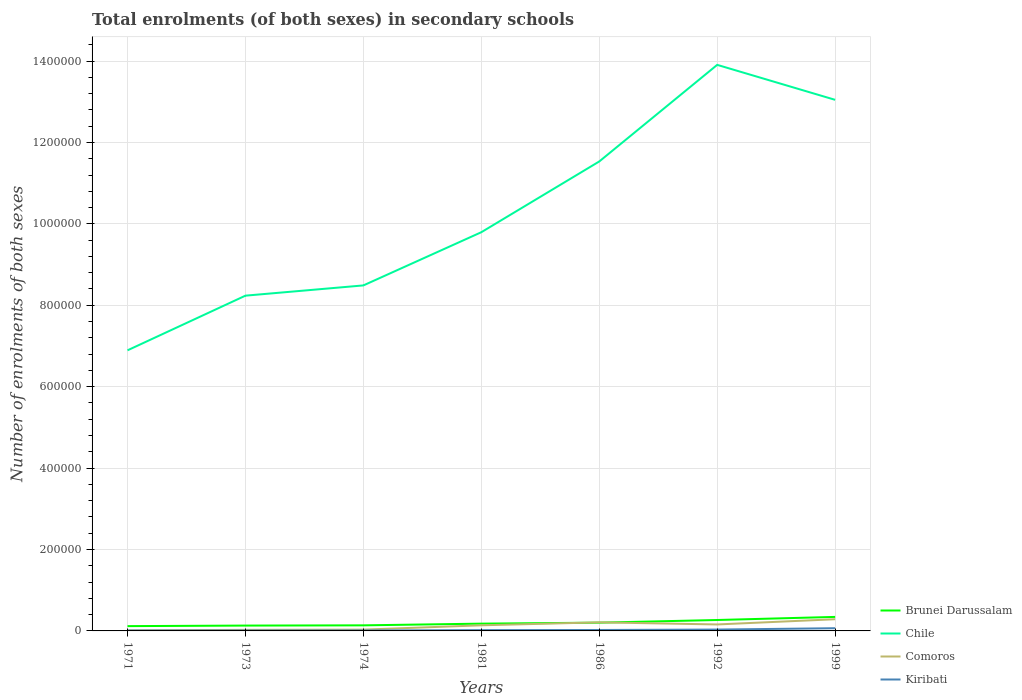How many different coloured lines are there?
Your answer should be very brief. 4. Across all years, what is the maximum number of enrolments in secondary schools in Chile?
Provide a short and direct response. 6.89e+05. What is the total number of enrolments in secondary schools in Chile in the graph?
Your answer should be very brief. -3.30e+05. What is the difference between the highest and the second highest number of enrolments in secondary schools in Brunei Darussalam?
Give a very brief answer. 2.26e+04. What is the difference between the highest and the lowest number of enrolments in secondary schools in Kiribati?
Offer a terse response. 2. How many lines are there?
Offer a very short reply. 4. Are the values on the major ticks of Y-axis written in scientific E-notation?
Your answer should be compact. No. What is the title of the graph?
Your response must be concise. Total enrolments (of both sexes) in secondary schools. Does "Nicaragua" appear as one of the legend labels in the graph?
Ensure brevity in your answer.  No. What is the label or title of the X-axis?
Offer a very short reply. Years. What is the label or title of the Y-axis?
Your response must be concise. Number of enrolments of both sexes. What is the Number of enrolments of both sexes in Brunei Darussalam in 1971?
Your answer should be very brief. 1.18e+04. What is the Number of enrolments of both sexes in Chile in 1971?
Give a very brief answer. 6.89e+05. What is the Number of enrolments of both sexes in Comoros in 1971?
Offer a very short reply. 1273. What is the Number of enrolments of both sexes in Kiribati in 1971?
Provide a succinct answer. 896. What is the Number of enrolments of both sexes in Brunei Darussalam in 1973?
Your response must be concise. 1.31e+04. What is the Number of enrolments of both sexes in Chile in 1973?
Provide a succinct answer. 8.24e+05. What is the Number of enrolments of both sexes of Comoros in 1973?
Your response must be concise. 2623. What is the Number of enrolments of both sexes in Kiribati in 1973?
Keep it short and to the point. 974. What is the Number of enrolments of both sexes of Brunei Darussalam in 1974?
Offer a terse response. 1.37e+04. What is the Number of enrolments of both sexes in Chile in 1974?
Keep it short and to the point. 8.49e+05. What is the Number of enrolments of both sexes of Comoros in 1974?
Your response must be concise. 3197. What is the Number of enrolments of both sexes in Kiribati in 1974?
Provide a short and direct response. 1055. What is the Number of enrolments of both sexes of Brunei Darussalam in 1981?
Your answer should be very brief. 1.79e+04. What is the Number of enrolments of both sexes of Chile in 1981?
Your response must be concise. 9.79e+05. What is the Number of enrolments of both sexes in Comoros in 1981?
Your response must be concise. 1.38e+04. What is the Number of enrolments of both sexes in Kiribati in 1981?
Your answer should be compact. 1900. What is the Number of enrolments of both sexes of Brunei Darussalam in 1986?
Provide a short and direct response. 2.03e+04. What is the Number of enrolments of both sexes in Chile in 1986?
Keep it short and to the point. 1.15e+06. What is the Number of enrolments of both sexes of Comoros in 1986?
Offer a terse response. 2.11e+04. What is the Number of enrolments of both sexes in Kiribati in 1986?
Offer a terse response. 2306. What is the Number of enrolments of both sexes in Brunei Darussalam in 1992?
Offer a terse response. 2.68e+04. What is the Number of enrolments of both sexes in Chile in 1992?
Provide a short and direct response. 1.39e+06. What is the Number of enrolments of both sexes in Comoros in 1992?
Give a very brief answer. 1.59e+04. What is the Number of enrolments of both sexes of Kiribati in 1992?
Make the answer very short. 3357. What is the Number of enrolments of both sexes in Brunei Darussalam in 1999?
Give a very brief answer. 3.44e+04. What is the Number of enrolments of both sexes in Chile in 1999?
Give a very brief answer. 1.30e+06. What is the Number of enrolments of both sexes in Comoros in 1999?
Provide a succinct answer. 2.87e+04. What is the Number of enrolments of both sexes in Kiribati in 1999?
Keep it short and to the point. 6647. Across all years, what is the maximum Number of enrolments of both sexes in Brunei Darussalam?
Your response must be concise. 3.44e+04. Across all years, what is the maximum Number of enrolments of both sexes of Chile?
Make the answer very short. 1.39e+06. Across all years, what is the maximum Number of enrolments of both sexes of Comoros?
Offer a terse response. 2.87e+04. Across all years, what is the maximum Number of enrolments of both sexes in Kiribati?
Provide a succinct answer. 6647. Across all years, what is the minimum Number of enrolments of both sexes in Brunei Darussalam?
Keep it short and to the point. 1.18e+04. Across all years, what is the minimum Number of enrolments of both sexes of Chile?
Ensure brevity in your answer.  6.89e+05. Across all years, what is the minimum Number of enrolments of both sexes of Comoros?
Your response must be concise. 1273. Across all years, what is the minimum Number of enrolments of both sexes in Kiribati?
Offer a terse response. 896. What is the total Number of enrolments of both sexes of Brunei Darussalam in the graph?
Your response must be concise. 1.38e+05. What is the total Number of enrolments of both sexes in Chile in the graph?
Provide a short and direct response. 7.19e+06. What is the total Number of enrolments of both sexes in Comoros in the graph?
Provide a short and direct response. 8.65e+04. What is the total Number of enrolments of both sexes in Kiribati in the graph?
Your answer should be compact. 1.71e+04. What is the difference between the Number of enrolments of both sexes in Brunei Darussalam in 1971 and that in 1973?
Make the answer very short. -1344. What is the difference between the Number of enrolments of both sexes in Chile in 1971 and that in 1973?
Offer a very short reply. -1.34e+05. What is the difference between the Number of enrolments of both sexes in Comoros in 1971 and that in 1973?
Make the answer very short. -1350. What is the difference between the Number of enrolments of both sexes in Kiribati in 1971 and that in 1973?
Your response must be concise. -78. What is the difference between the Number of enrolments of both sexes in Brunei Darussalam in 1971 and that in 1974?
Make the answer very short. -1903. What is the difference between the Number of enrolments of both sexes of Chile in 1971 and that in 1974?
Provide a succinct answer. -1.59e+05. What is the difference between the Number of enrolments of both sexes of Comoros in 1971 and that in 1974?
Provide a short and direct response. -1924. What is the difference between the Number of enrolments of both sexes of Kiribati in 1971 and that in 1974?
Your answer should be very brief. -159. What is the difference between the Number of enrolments of both sexes in Brunei Darussalam in 1971 and that in 1981?
Give a very brief answer. -6068. What is the difference between the Number of enrolments of both sexes of Chile in 1971 and that in 1981?
Provide a short and direct response. -2.90e+05. What is the difference between the Number of enrolments of both sexes of Comoros in 1971 and that in 1981?
Ensure brevity in your answer.  -1.25e+04. What is the difference between the Number of enrolments of both sexes of Kiribati in 1971 and that in 1981?
Your response must be concise. -1004. What is the difference between the Number of enrolments of both sexes of Brunei Darussalam in 1971 and that in 1986?
Offer a terse response. -8494. What is the difference between the Number of enrolments of both sexes in Chile in 1971 and that in 1986?
Offer a terse response. -4.64e+05. What is the difference between the Number of enrolments of both sexes of Comoros in 1971 and that in 1986?
Your answer should be very brief. -1.98e+04. What is the difference between the Number of enrolments of both sexes in Kiribati in 1971 and that in 1986?
Your answer should be very brief. -1410. What is the difference between the Number of enrolments of both sexes of Brunei Darussalam in 1971 and that in 1992?
Offer a very short reply. -1.50e+04. What is the difference between the Number of enrolments of both sexes of Chile in 1971 and that in 1992?
Your answer should be compact. -7.01e+05. What is the difference between the Number of enrolments of both sexes in Comoros in 1971 and that in 1992?
Your answer should be compact. -1.46e+04. What is the difference between the Number of enrolments of both sexes of Kiribati in 1971 and that in 1992?
Keep it short and to the point. -2461. What is the difference between the Number of enrolments of both sexes of Brunei Darussalam in 1971 and that in 1999?
Provide a succinct answer. -2.26e+04. What is the difference between the Number of enrolments of both sexes of Chile in 1971 and that in 1999?
Your answer should be compact. -6.15e+05. What is the difference between the Number of enrolments of both sexes in Comoros in 1971 and that in 1999?
Your answer should be very brief. -2.74e+04. What is the difference between the Number of enrolments of both sexes of Kiribati in 1971 and that in 1999?
Your answer should be compact. -5751. What is the difference between the Number of enrolments of both sexes in Brunei Darussalam in 1973 and that in 1974?
Your response must be concise. -559. What is the difference between the Number of enrolments of both sexes of Chile in 1973 and that in 1974?
Your response must be concise. -2.52e+04. What is the difference between the Number of enrolments of both sexes of Comoros in 1973 and that in 1974?
Keep it short and to the point. -574. What is the difference between the Number of enrolments of both sexes in Kiribati in 1973 and that in 1974?
Give a very brief answer. -81. What is the difference between the Number of enrolments of both sexes of Brunei Darussalam in 1973 and that in 1981?
Make the answer very short. -4724. What is the difference between the Number of enrolments of both sexes in Chile in 1973 and that in 1981?
Provide a succinct answer. -1.56e+05. What is the difference between the Number of enrolments of both sexes in Comoros in 1973 and that in 1981?
Provide a short and direct response. -1.12e+04. What is the difference between the Number of enrolments of both sexes of Kiribati in 1973 and that in 1981?
Offer a very short reply. -926. What is the difference between the Number of enrolments of both sexes of Brunei Darussalam in 1973 and that in 1986?
Your answer should be very brief. -7150. What is the difference between the Number of enrolments of both sexes of Chile in 1973 and that in 1986?
Your answer should be compact. -3.30e+05. What is the difference between the Number of enrolments of both sexes in Comoros in 1973 and that in 1986?
Your answer should be compact. -1.84e+04. What is the difference between the Number of enrolments of both sexes in Kiribati in 1973 and that in 1986?
Provide a short and direct response. -1332. What is the difference between the Number of enrolments of both sexes in Brunei Darussalam in 1973 and that in 1992?
Make the answer very short. -1.37e+04. What is the difference between the Number of enrolments of both sexes of Chile in 1973 and that in 1992?
Ensure brevity in your answer.  -5.67e+05. What is the difference between the Number of enrolments of both sexes of Comoros in 1973 and that in 1992?
Keep it short and to the point. -1.33e+04. What is the difference between the Number of enrolments of both sexes in Kiribati in 1973 and that in 1992?
Your response must be concise. -2383. What is the difference between the Number of enrolments of both sexes of Brunei Darussalam in 1973 and that in 1999?
Offer a terse response. -2.13e+04. What is the difference between the Number of enrolments of both sexes of Chile in 1973 and that in 1999?
Make the answer very short. -4.81e+05. What is the difference between the Number of enrolments of both sexes of Comoros in 1973 and that in 1999?
Offer a very short reply. -2.61e+04. What is the difference between the Number of enrolments of both sexes in Kiribati in 1973 and that in 1999?
Give a very brief answer. -5673. What is the difference between the Number of enrolments of both sexes in Brunei Darussalam in 1974 and that in 1981?
Offer a terse response. -4165. What is the difference between the Number of enrolments of both sexes of Chile in 1974 and that in 1981?
Provide a short and direct response. -1.31e+05. What is the difference between the Number of enrolments of both sexes in Comoros in 1974 and that in 1981?
Your answer should be very brief. -1.06e+04. What is the difference between the Number of enrolments of both sexes of Kiribati in 1974 and that in 1981?
Keep it short and to the point. -845. What is the difference between the Number of enrolments of both sexes in Brunei Darussalam in 1974 and that in 1986?
Offer a terse response. -6591. What is the difference between the Number of enrolments of both sexes of Chile in 1974 and that in 1986?
Ensure brevity in your answer.  -3.04e+05. What is the difference between the Number of enrolments of both sexes in Comoros in 1974 and that in 1986?
Make the answer very short. -1.79e+04. What is the difference between the Number of enrolments of both sexes in Kiribati in 1974 and that in 1986?
Your response must be concise. -1251. What is the difference between the Number of enrolments of both sexes in Brunei Darussalam in 1974 and that in 1992?
Your response must be concise. -1.31e+04. What is the difference between the Number of enrolments of both sexes in Chile in 1974 and that in 1992?
Give a very brief answer. -5.42e+05. What is the difference between the Number of enrolments of both sexes in Comoros in 1974 and that in 1992?
Provide a succinct answer. -1.27e+04. What is the difference between the Number of enrolments of both sexes of Kiribati in 1974 and that in 1992?
Keep it short and to the point. -2302. What is the difference between the Number of enrolments of both sexes of Brunei Darussalam in 1974 and that in 1999?
Provide a succinct answer. -2.07e+04. What is the difference between the Number of enrolments of both sexes in Chile in 1974 and that in 1999?
Keep it short and to the point. -4.56e+05. What is the difference between the Number of enrolments of both sexes of Comoros in 1974 and that in 1999?
Give a very brief answer. -2.55e+04. What is the difference between the Number of enrolments of both sexes in Kiribati in 1974 and that in 1999?
Provide a succinct answer. -5592. What is the difference between the Number of enrolments of both sexes of Brunei Darussalam in 1981 and that in 1986?
Your answer should be compact. -2426. What is the difference between the Number of enrolments of both sexes in Chile in 1981 and that in 1986?
Ensure brevity in your answer.  -1.74e+05. What is the difference between the Number of enrolments of both sexes in Comoros in 1981 and that in 1986?
Give a very brief answer. -7258. What is the difference between the Number of enrolments of both sexes in Kiribati in 1981 and that in 1986?
Ensure brevity in your answer.  -406. What is the difference between the Number of enrolments of both sexes of Brunei Darussalam in 1981 and that in 1992?
Ensure brevity in your answer.  -8967. What is the difference between the Number of enrolments of both sexes in Chile in 1981 and that in 1992?
Provide a short and direct response. -4.11e+05. What is the difference between the Number of enrolments of both sexes in Comoros in 1981 and that in 1992?
Make the answer very short. -2080. What is the difference between the Number of enrolments of both sexes in Kiribati in 1981 and that in 1992?
Make the answer very short. -1457. What is the difference between the Number of enrolments of both sexes in Brunei Darussalam in 1981 and that in 1999?
Your response must be concise. -1.66e+04. What is the difference between the Number of enrolments of both sexes in Chile in 1981 and that in 1999?
Your answer should be compact. -3.25e+05. What is the difference between the Number of enrolments of both sexes in Comoros in 1981 and that in 1999?
Offer a very short reply. -1.49e+04. What is the difference between the Number of enrolments of both sexes of Kiribati in 1981 and that in 1999?
Provide a short and direct response. -4747. What is the difference between the Number of enrolments of both sexes of Brunei Darussalam in 1986 and that in 1992?
Your response must be concise. -6541. What is the difference between the Number of enrolments of both sexes in Chile in 1986 and that in 1992?
Offer a very short reply. -2.37e+05. What is the difference between the Number of enrolments of both sexes of Comoros in 1986 and that in 1992?
Give a very brief answer. 5178. What is the difference between the Number of enrolments of both sexes of Kiribati in 1986 and that in 1992?
Your response must be concise. -1051. What is the difference between the Number of enrolments of both sexes of Brunei Darussalam in 1986 and that in 1999?
Offer a very short reply. -1.41e+04. What is the difference between the Number of enrolments of both sexes of Chile in 1986 and that in 1999?
Give a very brief answer. -1.51e+05. What is the difference between the Number of enrolments of both sexes in Comoros in 1986 and that in 1999?
Your response must be concise. -7662. What is the difference between the Number of enrolments of both sexes of Kiribati in 1986 and that in 1999?
Provide a short and direct response. -4341. What is the difference between the Number of enrolments of both sexes in Brunei Darussalam in 1992 and that in 1999?
Ensure brevity in your answer.  -7590. What is the difference between the Number of enrolments of both sexes of Chile in 1992 and that in 1999?
Keep it short and to the point. 8.59e+04. What is the difference between the Number of enrolments of both sexes in Comoros in 1992 and that in 1999?
Offer a very short reply. -1.28e+04. What is the difference between the Number of enrolments of both sexes of Kiribati in 1992 and that in 1999?
Offer a very short reply. -3290. What is the difference between the Number of enrolments of both sexes in Brunei Darussalam in 1971 and the Number of enrolments of both sexes in Chile in 1973?
Your answer should be compact. -8.12e+05. What is the difference between the Number of enrolments of both sexes in Brunei Darussalam in 1971 and the Number of enrolments of both sexes in Comoros in 1973?
Keep it short and to the point. 9178. What is the difference between the Number of enrolments of both sexes of Brunei Darussalam in 1971 and the Number of enrolments of both sexes of Kiribati in 1973?
Keep it short and to the point. 1.08e+04. What is the difference between the Number of enrolments of both sexes of Chile in 1971 and the Number of enrolments of both sexes of Comoros in 1973?
Your answer should be compact. 6.87e+05. What is the difference between the Number of enrolments of both sexes of Chile in 1971 and the Number of enrolments of both sexes of Kiribati in 1973?
Your response must be concise. 6.88e+05. What is the difference between the Number of enrolments of both sexes in Comoros in 1971 and the Number of enrolments of both sexes in Kiribati in 1973?
Provide a succinct answer. 299. What is the difference between the Number of enrolments of both sexes of Brunei Darussalam in 1971 and the Number of enrolments of both sexes of Chile in 1974?
Provide a succinct answer. -8.37e+05. What is the difference between the Number of enrolments of both sexes in Brunei Darussalam in 1971 and the Number of enrolments of both sexes in Comoros in 1974?
Your answer should be compact. 8604. What is the difference between the Number of enrolments of both sexes in Brunei Darussalam in 1971 and the Number of enrolments of both sexes in Kiribati in 1974?
Keep it short and to the point. 1.07e+04. What is the difference between the Number of enrolments of both sexes of Chile in 1971 and the Number of enrolments of both sexes of Comoros in 1974?
Keep it short and to the point. 6.86e+05. What is the difference between the Number of enrolments of both sexes of Chile in 1971 and the Number of enrolments of both sexes of Kiribati in 1974?
Keep it short and to the point. 6.88e+05. What is the difference between the Number of enrolments of both sexes of Comoros in 1971 and the Number of enrolments of both sexes of Kiribati in 1974?
Ensure brevity in your answer.  218. What is the difference between the Number of enrolments of both sexes of Brunei Darussalam in 1971 and the Number of enrolments of both sexes of Chile in 1981?
Provide a short and direct response. -9.68e+05. What is the difference between the Number of enrolments of both sexes in Brunei Darussalam in 1971 and the Number of enrolments of both sexes in Comoros in 1981?
Offer a terse response. -1997. What is the difference between the Number of enrolments of both sexes in Brunei Darussalam in 1971 and the Number of enrolments of both sexes in Kiribati in 1981?
Offer a very short reply. 9901. What is the difference between the Number of enrolments of both sexes of Chile in 1971 and the Number of enrolments of both sexes of Comoros in 1981?
Your answer should be very brief. 6.76e+05. What is the difference between the Number of enrolments of both sexes of Chile in 1971 and the Number of enrolments of both sexes of Kiribati in 1981?
Provide a short and direct response. 6.87e+05. What is the difference between the Number of enrolments of both sexes in Comoros in 1971 and the Number of enrolments of both sexes in Kiribati in 1981?
Keep it short and to the point. -627. What is the difference between the Number of enrolments of both sexes of Brunei Darussalam in 1971 and the Number of enrolments of both sexes of Chile in 1986?
Offer a terse response. -1.14e+06. What is the difference between the Number of enrolments of both sexes of Brunei Darussalam in 1971 and the Number of enrolments of both sexes of Comoros in 1986?
Your answer should be very brief. -9255. What is the difference between the Number of enrolments of both sexes in Brunei Darussalam in 1971 and the Number of enrolments of both sexes in Kiribati in 1986?
Your answer should be compact. 9495. What is the difference between the Number of enrolments of both sexes in Chile in 1971 and the Number of enrolments of both sexes in Comoros in 1986?
Provide a short and direct response. 6.68e+05. What is the difference between the Number of enrolments of both sexes of Chile in 1971 and the Number of enrolments of both sexes of Kiribati in 1986?
Give a very brief answer. 6.87e+05. What is the difference between the Number of enrolments of both sexes of Comoros in 1971 and the Number of enrolments of both sexes of Kiribati in 1986?
Make the answer very short. -1033. What is the difference between the Number of enrolments of both sexes in Brunei Darussalam in 1971 and the Number of enrolments of both sexes in Chile in 1992?
Ensure brevity in your answer.  -1.38e+06. What is the difference between the Number of enrolments of both sexes of Brunei Darussalam in 1971 and the Number of enrolments of both sexes of Comoros in 1992?
Offer a terse response. -4077. What is the difference between the Number of enrolments of both sexes in Brunei Darussalam in 1971 and the Number of enrolments of both sexes in Kiribati in 1992?
Ensure brevity in your answer.  8444. What is the difference between the Number of enrolments of both sexes of Chile in 1971 and the Number of enrolments of both sexes of Comoros in 1992?
Your answer should be very brief. 6.73e+05. What is the difference between the Number of enrolments of both sexes in Chile in 1971 and the Number of enrolments of both sexes in Kiribati in 1992?
Provide a succinct answer. 6.86e+05. What is the difference between the Number of enrolments of both sexes in Comoros in 1971 and the Number of enrolments of both sexes in Kiribati in 1992?
Make the answer very short. -2084. What is the difference between the Number of enrolments of both sexes in Brunei Darussalam in 1971 and the Number of enrolments of both sexes in Chile in 1999?
Your answer should be very brief. -1.29e+06. What is the difference between the Number of enrolments of both sexes of Brunei Darussalam in 1971 and the Number of enrolments of both sexes of Comoros in 1999?
Offer a terse response. -1.69e+04. What is the difference between the Number of enrolments of both sexes of Brunei Darussalam in 1971 and the Number of enrolments of both sexes of Kiribati in 1999?
Your answer should be compact. 5154. What is the difference between the Number of enrolments of both sexes of Chile in 1971 and the Number of enrolments of both sexes of Comoros in 1999?
Keep it short and to the point. 6.61e+05. What is the difference between the Number of enrolments of both sexes of Chile in 1971 and the Number of enrolments of both sexes of Kiribati in 1999?
Offer a very short reply. 6.83e+05. What is the difference between the Number of enrolments of both sexes in Comoros in 1971 and the Number of enrolments of both sexes in Kiribati in 1999?
Your response must be concise. -5374. What is the difference between the Number of enrolments of both sexes in Brunei Darussalam in 1973 and the Number of enrolments of both sexes in Chile in 1974?
Your response must be concise. -8.36e+05. What is the difference between the Number of enrolments of both sexes of Brunei Darussalam in 1973 and the Number of enrolments of both sexes of Comoros in 1974?
Your answer should be very brief. 9948. What is the difference between the Number of enrolments of both sexes in Brunei Darussalam in 1973 and the Number of enrolments of both sexes in Kiribati in 1974?
Keep it short and to the point. 1.21e+04. What is the difference between the Number of enrolments of both sexes in Chile in 1973 and the Number of enrolments of both sexes in Comoros in 1974?
Keep it short and to the point. 8.20e+05. What is the difference between the Number of enrolments of both sexes of Chile in 1973 and the Number of enrolments of both sexes of Kiribati in 1974?
Offer a very short reply. 8.23e+05. What is the difference between the Number of enrolments of both sexes of Comoros in 1973 and the Number of enrolments of both sexes of Kiribati in 1974?
Provide a succinct answer. 1568. What is the difference between the Number of enrolments of both sexes in Brunei Darussalam in 1973 and the Number of enrolments of both sexes in Chile in 1981?
Provide a succinct answer. -9.66e+05. What is the difference between the Number of enrolments of both sexes of Brunei Darussalam in 1973 and the Number of enrolments of both sexes of Comoros in 1981?
Provide a succinct answer. -653. What is the difference between the Number of enrolments of both sexes in Brunei Darussalam in 1973 and the Number of enrolments of both sexes in Kiribati in 1981?
Provide a short and direct response. 1.12e+04. What is the difference between the Number of enrolments of both sexes in Chile in 1973 and the Number of enrolments of both sexes in Comoros in 1981?
Provide a short and direct response. 8.10e+05. What is the difference between the Number of enrolments of both sexes in Chile in 1973 and the Number of enrolments of both sexes in Kiribati in 1981?
Provide a succinct answer. 8.22e+05. What is the difference between the Number of enrolments of both sexes of Comoros in 1973 and the Number of enrolments of both sexes of Kiribati in 1981?
Ensure brevity in your answer.  723. What is the difference between the Number of enrolments of both sexes of Brunei Darussalam in 1973 and the Number of enrolments of both sexes of Chile in 1986?
Keep it short and to the point. -1.14e+06. What is the difference between the Number of enrolments of both sexes of Brunei Darussalam in 1973 and the Number of enrolments of both sexes of Comoros in 1986?
Give a very brief answer. -7911. What is the difference between the Number of enrolments of both sexes of Brunei Darussalam in 1973 and the Number of enrolments of both sexes of Kiribati in 1986?
Make the answer very short. 1.08e+04. What is the difference between the Number of enrolments of both sexes in Chile in 1973 and the Number of enrolments of both sexes in Comoros in 1986?
Your response must be concise. 8.03e+05. What is the difference between the Number of enrolments of both sexes of Chile in 1973 and the Number of enrolments of both sexes of Kiribati in 1986?
Offer a very short reply. 8.21e+05. What is the difference between the Number of enrolments of both sexes in Comoros in 1973 and the Number of enrolments of both sexes in Kiribati in 1986?
Your response must be concise. 317. What is the difference between the Number of enrolments of both sexes in Brunei Darussalam in 1973 and the Number of enrolments of both sexes in Chile in 1992?
Provide a succinct answer. -1.38e+06. What is the difference between the Number of enrolments of both sexes in Brunei Darussalam in 1973 and the Number of enrolments of both sexes in Comoros in 1992?
Make the answer very short. -2733. What is the difference between the Number of enrolments of both sexes of Brunei Darussalam in 1973 and the Number of enrolments of both sexes of Kiribati in 1992?
Your response must be concise. 9788. What is the difference between the Number of enrolments of both sexes of Chile in 1973 and the Number of enrolments of both sexes of Comoros in 1992?
Your answer should be compact. 8.08e+05. What is the difference between the Number of enrolments of both sexes in Chile in 1973 and the Number of enrolments of both sexes in Kiribati in 1992?
Your answer should be very brief. 8.20e+05. What is the difference between the Number of enrolments of both sexes of Comoros in 1973 and the Number of enrolments of both sexes of Kiribati in 1992?
Make the answer very short. -734. What is the difference between the Number of enrolments of both sexes in Brunei Darussalam in 1973 and the Number of enrolments of both sexes in Chile in 1999?
Your answer should be very brief. -1.29e+06. What is the difference between the Number of enrolments of both sexes of Brunei Darussalam in 1973 and the Number of enrolments of both sexes of Comoros in 1999?
Ensure brevity in your answer.  -1.56e+04. What is the difference between the Number of enrolments of both sexes of Brunei Darussalam in 1973 and the Number of enrolments of both sexes of Kiribati in 1999?
Offer a very short reply. 6498. What is the difference between the Number of enrolments of both sexes in Chile in 1973 and the Number of enrolments of both sexes in Comoros in 1999?
Provide a short and direct response. 7.95e+05. What is the difference between the Number of enrolments of both sexes in Chile in 1973 and the Number of enrolments of both sexes in Kiribati in 1999?
Make the answer very short. 8.17e+05. What is the difference between the Number of enrolments of both sexes in Comoros in 1973 and the Number of enrolments of both sexes in Kiribati in 1999?
Provide a succinct answer. -4024. What is the difference between the Number of enrolments of both sexes of Brunei Darussalam in 1974 and the Number of enrolments of both sexes of Chile in 1981?
Ensure brevity in your answer.  -9.66e+05. What is the difference between the Number of enrolments of both sexes in Brunei Darussalam in 1974 and the Number of enrolments of both sexes in Comoros in 1981?
Offer a terse response. -94. What is the difference between the Number of enrolments of both sexes of Brunei Darussalam in 1974 and the Number of enrolments of both sexes of Kiribati in 1981?
Provide a short and direct response. 1.18e+04. What is the difference between the Number of enrolments of both sexes of Chile in 1974 and the Number of enrolments of both sexes of Comoros in 1981?
Your response must be concise. 8.35e+05. What is the difference between the Number of enrolments of both sexes of Chile in 1974 and the Number of enrolments of both sexes of Kiribati in 1981?
Your answer should be very brief. 8.47e+05. What is the difference between the Number of enrolments of both sexes in Comoros in 1974 and the Number of enrolments of both sexes in Kiribati in 1981?
Your answer should be very brief. 1297. What is the difference between the Number of enrolments of both sexes in Brunei Darussalam in 1974 and the Number of enrolments of both sexes in Chile in 1986?
Your answer should be very brief. -1.14e+06. What is the difference between the Number of enrolments of both sexes of Brunei Darussalam in 1974 and the Number of enrolments of both sexes of Comoros in 1986?
Your answer should be very brief. -7352. What is the difference between the Number of enrolments of both sexes in Brunei Darussalam in 1974 and the Number of enrolments of both sexes in Kiribati in 1986?
Keep it short and to the point. 1.14e+04. What is the difference between the Number of enrolments of both sexes of Chile in 1974 and the Number of enrolments of both sexes of Comoros in 1986?
Offer a terse response. 8.28e+05. What is the difference between the Number of enrolments of both sexes of Chile in 1974 and the Number of enrolments of both sexes of Kiribati in 1986?
Provide a short and direct response. 8.46e+05. What is the difference between the Number of enrolments of both sexes in Comoros in 1974 and the Number of enrolments of both sexes in Kiribati in 1986?
Provide a short and direct response. 891. What is the difference between the Number of enrolments of both sexes in Brunei Darussalam in 1974 and the Number of enrolments of both sexes in Chile in 1992?
Ensure brevity in your answer.  -1.38e+06. What is the difference between the Number of enrolments of both sexes of Brunei Darussalam in 1974 and the Number of enrolments of both sexes of Comoros in 1992?
Offer a very short reply. -2174. What is the difference between the Number of enrolments of both sexes of Brunei Darussalam in 1974 and the Number of enrolments of both sexes of Kiribati in 1992?
Ensure brevity in your answer.  1.03e+04. What is the difference between the Number of enrolments of both sexes in Chile in 1974 and the Number of enrolments of both sexes in Comoros in 1992?
Your answer should be compact. 8.33e+05. What is the difference between the Number of enrolments of both sexes of Chile in 1974 and the Number of enrolments of both sexes of Kiribati in 1992?
Provide a short and direct response. 8.45e+05. What is the difference between the Number of enrolments of both sexes of Comoros in 1974 and the Number of enrolments of both sexes of Kiribati in 1992?
Your answer should be very brief. -160. What is the difference between the Number of enrolments of both sexes in Brunei Darussalam in 1974 and the Number of enrolments of both sexes in Chile in 1999?
Your answer should be compact. -1.29e+06. What is the difference between the Number of enrolments of both sexes of Brunei Darussalam in 1974 and the Number of enrolments of both sexes of Comoros in 1999?
Offer a very short reply. -1.50e+04. What is the difference between the Number of enrolments of both sexes in Brunei Darussalam in 1974 and the Number of enrolments of both sexes in Kiribati in 1999?
Give a very brief answer. 7057. What is the difference between the Number of enrolments of both sexes in Chile in 1974 and the Number of enrolments of both sexes in Comoros in 1999?
Offer a very short reply. 8.20e+05. What is the difference between the Number of enrolments of both sexes in Chile in 1974 and the Number of enrolments of both sexes in Kiribati in 1999?
Your answer should be very brief. 8.42e+05. What is the difference between the Number of enrolments of both sexes of Comoros in 1974 and the Number of enrolments of both sexes of Kiribati in 1999?
Your answer should be compact. -3450. What is the difference between the Number of enrolments of both sexes of Brunei Darussalam in 1981 and the Number of enrolments of both sexes of Chile in 1986?
Ensure brevity in your answer.  -1.14e+06. What is the difference between the Number of enrolments of both sexes in Brunei Darussalam in 1981 and the Number of enrolments of both sexes in Comoros in 1986?
Provide a succinct answer. -3187. What is the difference between the Number of enrolments of both sexes in Brunei Darussalam in 1981 and the Number of enrolments of both sexes in Kiribati in 1986?
Your response must be concise. 1.56e+04. What is the difference between the Number of enrolments of both sexes of Chile in 1981 and the Number of enrolments of both sexes of Comoros in 1986?
Ensure brevity in your answer.  9.58e+05. What is the difference between the Number of enrolments of both sexes of Chile in 1981 and the Number of enrolments of both sexes of Kiribati in 1986?
Ensure brevity in your answer.  9.77e+05. What is the difference between the Number of enrolments of both sexes in Comoros in 1981 and the Number of enrolments of both sexes in Kiribati in 1986?
Your answer should be very brief. 1.15e+04. What is the difference between the Number of enrolments of both sexes in Brunei Darussalam in 1981 and the Number of enrolments of both sexes in Chile in 1992?
Provide a short and direct response. -1.37e+06. What is the difference between the Number of enrolments of both sexes in Brunei Darussalam in 1981 and the Number of enrolments of both sexes in Comoros in 1992?
Provide a succinct answer. 1991. What is the difference between the Number of enrolments of both sexes in Brunei Darussalam in 1981 and the Number of enrolments of both sexes in Kiribati in 1992?
Offer a very short reply. 1.45e+04. What is the difference between the Number of enrolments of both sexes of Chile in 1981 and the Number of enrolments of both sexes of Comoros in 1992?
Offer a terse response. 9.64e+05. What is the difference between the Number of enrolments of both sexes in Chile in 1981 and the Number of enrolments of both sexes in Kiribati in 1992?
Give a very brief answer. 9.76e+05. What is the difference between the Number of enrolments of both sexes of Comoros in 1981 and the Number of enrolments of both sexes of Kiribati in 1992?
Ensure brevity in your answer.  1.04e+04. What is the difference between the Number of enrolments of both sexes of Brunei Darussalam in 1981 and the Number of enrolments of both sexes of Chile in 1999?
Give a very brief answer. -1.29e+06. What is the difference between the Number of enrolments of both sexes in Brunei Darussalam in 1981 and the Number of enrolments of both sexes in Comoros in 1999?
Keep it short and to the point. -1.08e+04. What is the difference between the Number of enrolments of both sexes of Brunei Darussalam in 1981 and the Number of enrolments of both sexes of Kiribati in 1999?
Provide a short and direct response. 1.12e+04. What is the difference between the Number of enrolments of both sexes in Chile in 1981 and the Number of enrolments of both sexes in Comoros in 1999?
Provide a succinct answer. 9.51e+05. What is the difference between the Number of enrolments of both sexes in Chile in 1981 and the Number of enrolments of both sexes in Kiribati in 1999?
Provide a short and direct response. 9.73e+05. What is the difference between the Number of enrolments of both sexes in Comoros in 1981 and the Number of enrolments of both sexes in Kiribati in 1999?
Ensure brevity in your answer.  7151. What is the difference between the Number of enrolments of both sexes of Brunei Darussalam in 1986 and the Number of enrolments of both sexes of Chile in 1992?
Your answer should be very brief. -1.37e+06. What is the difference between the Number of enrolments of both sexes of Brunei Darussalam in 1986 and the Number of enrolments of both sexes of Comoros in 1992?
Your answer should be very brief. 4417. What is the difference between the Number of enrolments of both sexes of Brunei Darussalam in 1986 and the Number of enrolments of both sexes of Kiribati in 1992?
Make the answer very short. 1.69e+04. What is the difference between the Number of enrolments of both sexes of Chile in 1986 and the Number of enrolments of both sexes of Comoros in 1992?
Ensure brevity in your answer.  1.14e+06. What is the difference between the Number of enrolments of both sexes in Chile in 1986 and the Number of enrolments of both sexes in Kiribati in 1992?
Offer a terse response. 1.15e+06. What is the difference between the Number of enrolments of both sexes in Comoros in 1986 and the Number of enrolments of both sexes in Kiribati in 1992?
Provide a short and direct response. 1.77e+04. What is the difference between the Number of enrolments of both sexes of Brunei Darussalam in 1986 and the Number of enrolments of both sexes of Chile in 1999?
Offer a terse response. -1.28e+06. What is the difference between the Number of enrolments of both sexes of Brunei Darussalam in 1986 and the Number of enrolments of both sexes of Comoros in 1999?
Your answer should be very brief. -8423. What is the difference between the Number of enrolments of both sexes in Brunei Darussalam in 1986 and the Number of enrolments of both sexes in Kiribati in 1999?
Your answer should be very brief. 1.36e+04. What is the difference between the Number of enrolments of both sexes of Chile in 1986 and the Number of enrolments of both sexes of Comoros in 1999?
Provide a succinct answer. 1.12e+06. What is the difference between the Number of enrolments of both sexes in Chile in 1986 and the Number of enrolments of both sexes in Kiribati in 1999?
Keep it short and to the point. 1.15e+06. What is the difference between the Number of enrolments of both sexes in Comoros in 1986 and the Number of enrolments of both sexes in Kiribati in 1999?
Your response must be concise. 1.44e+04. What is the difference between the Number of enrolments of both sexes in Brunei Darussalam in 1992 and the Number of enrolments of both sexes in Chile in 1999?
Keep it short and to the point. -1.28e+06. What is the difference between the Number of enrolments of both sexes of Brunei Darussalam in 1992 and the Number of enrolments of both sexes of Comoros in 1999?
Make the answer very short. -1882. What is the difference between the Number of enrolments of both sexes in Brunei Darussalam in 1992 and the Number of enrolments of both sexes in Kiribati in 1999?
Your response must be concise. 2.02e+04. What is the difference between the Number of enrolments of both sexes in Chile in 1992 and the Number of enrolments of both sexes in Comoros in 1999?
Ensure brevity in your answer.  1.36e+06. What is the difference between the Number of enrolments of both sexes in Chile in 1992 and the Number of enrolments of both sexes in Kiribati in 1999?
Your response must be concise. 1.38e+06. What is the difference between the Number of enrolments of both sexes in Comoros in 1992 and the Number of enrolments of both sexes in Kiribati in 1999?
Your response must be concise. 9231. What is the average Number of enrolments of both sexes in Brunei Darussalam per year?
Keep it short and to the point. 1.97e+04. What is the average Number of enrolments of both sexes in Chile per year?
Offer a very short reply. 1.03e+06. What is the average Number of enrolments of both sexes in Comoros per year?
Offer a terse response. 1.24e+04. What is the average Number of enrolments of both sexes of Kiribati per year?
Offer a terse response. 2447.86. In the year 1971, what is the difference between the Number of enrolments of both sexes in Brunei Darussalam and Number of enrolments of both sexes in Chile?
Ensure brevity in your answer.  -6.78e+05. In the year 1971, what is the difference between the Number of enrolments of both sexes in Brunei Darussalam and Number of enrolments of both sexes in Comoros?
Offer a very short reply. 1.05e+04. In the year 1971, what is the difference between the Number of enrolments of both sexes in Brunei Darussalam and Number of enrolments of both sexes in Kiribati?
Ensure brevity in your answer.  1.09e+04. In the year 1971, what is the difference between the Number of enrolments of both sexes in Chile and Number of enrolments of both sexes in Comoros?
Provide a succinct answer. 6.88e+05. In the year 1971, what is the difference between the Number of enrolments of both sexes of Chile and Number of enrolments of both sexes of Kiribati?
Give a very brief answer. 6.88e+05. In the year 1971, what is the difference between the Number of enrolments of both sexes of Comoros and Number of enrolments of both sexes of Kiribati?
Your response must be concise. 377. In the year 1973, what is the difference between the Number of enrolments of both sexes of Brunei Darussalam and Number of enrolments of both sexes of Chile?
Give a very brief answer. -8.10e+05. In the year 1973, what is the difference between the Number of enrolments of both sexes in Brunei Darussalam and Number of enrolments of both sexes in Comoros?
Offer a very short reply. 1.05e+04. In the year 1973, what is the difference between the Number of enrolments of both sexes of Brunei Darussalam and Number of enrolments of both sexes of Kiribati?
Make the answer very short. 1.22e+04. In the year 1973, what is the difference between the Number of enrolments of both sexes of Chile and Number of enrolments of both sexes of Comoros?
Your answer should be very brief. 8.21e+05. In the year 1973, what is the difference between the Number of enrolments of both sexes of Chile and Number of enrolments of both sexes of Kiribati?
Provide a succinct answer. 8.23e+05. In the year 1973, what is the difference between the Number of enrolments of both sexes of Comoros and Number of enrolments of both sexes of Kiribati?
Provide a short and direct response. 1649. In the year 1974, what is the difference between the Number of enrolments of both sexes of Brunei Darussalam and Number of enrolments of both sexes of Chile?
Provide a short and direct response. -8.35e+05. In the year 1974, what is the difference between the Number of enrolments of both sexes in Brunei Darussalam and Number of enrolments of both sexes in Comoros?
Keep it short and to the point. 1.05e+04. In the year 1974, what is the difference between the Number of enrolments of both sexes in Brunei Darussalam and Number of enrolments of both sexes in Kiribati?
Your answer should be compact. 1.26e+04. In the year 1974, what is the difference between the Number of enrolments of both sexes of Chile and Number of enrolments of both sexes of Comoros?
Give a very brief answer. 8.46e+05. In the year 1974, what is the difference between the Number of enrolments of both sexes of Chile and Number of enrolments of both sexes of Kiribati?
Give a very brief answer. 8.48e+05. In the year 1974, what is the difference between the Number of enrolments of both sexes in Comoros and Number of enrolments of both sexes in Kiribati?
Make the answer very short. 2142. In the year 1981, what is the difference between the Number of enrolments of both sexes in Brunei Darussalam and Number of enrolments of both sexes in Chile?
Provide a succinct answer. -9.62e+05. In the year 1981, what is the difference between the Number of enrolments of both sexes in Brunei Darussalam and Number of enrolments of both sexes in Comoros?
Your answer should be compact. 4071. In the year 1981, what is the difference between the Number of enrolments of both sexes of Brunei Darussalam and Number of enrolments of both sexes of Kiribati?
Provide a short and direct response. 1.60e+04. In the year 1981, what is the difference between the Number of enrolments of both sexes in Chile and Number of enrolments of both sexes in Comoros?
Your response must be concise. 9.66e+05. In the year 1981, what is the difference between the Number of enrolments of both sexes in Chile and Number of enrolments of both sexes in Kiribati?
Ensure brevity in your answer.  9.78e+05. In the year 1981, what is the difference between the Number of enrolments of both sexes in Comoros and Number of enrolments of both sexes in Kiribati?
Offer a very short reply. 1.19e+04. In the year 1986, what is the difference between the Number of enrolments of both sexes of Brunei Darussalam and Number of enrolments of both sexes of Chile?
Give a very brief answer. -1.13e+06. In the year 1986, what is the difference between the Number of enrolments of both sexes of Brunei Darussalam and Number of enrolments of both sexes of Comoros?
Keep it short and to the point. -761. In the year 1986, what is the difference between the Number of enrolments of both sexes of Brunei Darussalam and Number of enrolments of both sexes of Kiribati?
Keep it short and to the point. 1.80e+04. In the year 1986, what is the difference between the Number of enrolments of both sexes in Chile and Number of enrolments of both sexes in Comoros?
Offer a terse response. 1.13e+06. In the year 1986, what is the difference between the Number of enrolments of both sexes in Chile and Number of enrolments of both sexes in Kiribati?
Ensure brevity in your answer.  1.15e+06. In the year 1986, what is the difference between the Number of enrolments of both sexes of Comoros and Number of enrolments of both sexes of Kiribati?
Make the answer very short. 1.88e+04. In the year 1992, what is the difference between the Number of enrolments of both sexes in Brunei Darussalam and Number of enrolments of both sexes in Chile?
Ensure brevity in your answer.  -1.36e+06. In the year 1992, what is the difference between the Number of enrolments of both sexes of Brunei Darussalam and Number of enrolments of both sexes of Comoros?
Offer a very short reply. 1.10e+04. In the year 1992, what is the difference between the Number of enrolments of both sexes of Brunei Darussalam and Number of enrolments of both sexes of Kiribati?
Keep it short and to the point. 2.35e+04. In the year 1992, what is the difference between the Number of enrolments of both sexes of Chile and Number of enrolments of both sexes of Comoros?
Your response must be concise. 1.37e+06. In the year 1992, what is the difference between the Number of enrolments of both sexes in Chile and Number of enrolments of both sexes in Kiribati?
Make the answer very short. 1.39e+06. In the year 1992, what is the difference between the Number of enrolments of both sexes in Comoros and Number of enrolments of both sexes in Kiribati?
Keep it short and to the point. 1.25e+04. In the year 1999, what is the difference between the Number of enrolments of both sexes in Brunei Darussalam and Number of enrolments of both sexes in Chile?
Make the answer very short. -1.27e+06. In the year 1999, what is the difference between the Number of enrolments of both sexes in Brunei Darussalam and Number of enrolments of both sexes in Comoros?
Keep it short and to the point. 5708. In the year 1999, what is the difference between the Number of enrolments of both sexes of Brunei Darussalam and Number of enrolments of both sexes of Kiribati?
Give a very brief answer. 2.78e+04. In the year 1999, what is the difference between the Number of enrolments of both sexes of Chile and Number of enrolments of both sexes of Comoros?
Your answer should be compact. 1.28e+06. In the year 1999, what is the difference between the Number of enrolments of both sexes in Chile and Number of enrolments of both sexes in Kiribati?
Your response must be concise. 1.30e+06. In the year 1999, what is the difference between the Number of enrolments of both sexes of Comoros and Number of enrolments of both sexes of Kiribati?
Ensure brevity in your answer.  2.21e+04. What is the ratio of the Number of enrolments of both sexes in Brunei Darussalam in 1971 to that in 1973?
Keep it short and to the point. 0.9. What is the ratio of the Number of enrolments of both sexes in Chile in 1971 to that in 1973?
Ensure brevity in your answer.  0.84. What is the ratio of the Number of enrolments of both sexes in Comoros in 1971 to that in 1973?
Provide a short and direct response. 0.49. What is the ratio of the Number of enrolments of both sexes of Kiribati in 1971 to that in 1973?
Your response must be concise. 0.92. What is the ratio of the Number of enrolments of both sexes in Brunei Darussalam in 1971 to that in 1974?
Keep it short and to the point. 0.86. What is the ratio of the Number of enrolments of both sexes in Chile in 1971 to that in 1974?
Offer a terse response. 0.81. What is the ratio of the Number of enrolments of both sexes in Comoros in 1971 to that in 1974?
Offer a very short reply. 0.4. What is the ratio of the Number of enrolments of both sexes in Kiribati in 1971 to that in 1974?
Ensure brevity in your answer.  0.85. What is the ratio of the Number of enrolments of both sexes of Brunei Darussalam in 1971 to that in 1981?
Your response must be concise. 0.66. What is the ratio of the Number of enrolments of both sexes in Chile in 1971 to that in 1981?
Give a very brief answer. 0.7. What is the ratio of the Number of enrolments of both sexes of Comoros in 1971 to that in 1981?
Your answer should be very brief. 0.09. What is the ratio of the Number of enrolments of both sexes in Kiribati in 1971 to that in 1981?
Offer a very short reply. 0.47. What is the ratio of the Number of enrolments of both sexes of Brunei Darussalam in 1971 to that in 1986?
Ensure brevity in your answer.  0.58. What is the ratio of the Number of enrolments of both sexes in Chile in 1971 to that in 1986?
Offer a very short reply. 0.6. What is the ratio of the Number of enrolments of both sexes of Comoros in 1971 to that in 1986?
Provide a short and direct response. 0.06. What is the ratio of the Number of enrolments of both sexes of Kiribati in 1971 to that in 1986?
Offer a very short reply. 0.39. What is the ratio of the Number of enrolments of both sexes in Brunei Darussalam in 1971 to that in 1992?
Give a very brief answer. 0.44. What is the ratio of the Number of enrolments of both sexes in Chile in 1971 to that in 1992?
Provide a succinct answer. 0.5. What is the ratio of the Number of enrolments of both sexes in Comoros in 1971 to that in 1992?
Your answer should be compact. 0.08. What is the ratio of the Number of enrolments of both sexes of Kiribati in 1971 to that in 1992?
Your answer should be compact. 0.27. What is the ratio of the Number of enrolments of both sexes in Brunei Darussalam in 1971 to that in 1999?
Your response must be concise. 0.34. What is the ratio of the Number of enrolments of both sexes in Chile in 1971 to that in 1999?
Your answer should be very brief. 0.53. What is the ratio of the Number of enrolments of both sexes of Comoros in 1971 to that in 1999?
Offer a very short reply. 0.04. What is the ratio of the Number of enrolments of both sexes of Kiribati in 1971 to that in 1999?
Make the answer very short. 0.13. What is the ratio of the Number of enrolments of both sexes in Brunei Darussalam in 1973 to that in 1974?
Make the answer very short. 0.96. What is the ratio of the Number of enrolments of both sexes of Chile in 1973 to that in 1974?
Offer a very short reply. 0.97. What is the ratio of the Number of enrolments of both sexes of Comoros in 1973 to that in 1974?
Your response must be concise. 0.82. What is the ratio of the Number of enrolments of both sexes in Kiribati in 1973 to that in 1974?
Your answer should be compact. 0.92. What is the ratio of the Number of enrolments of both sexes in Brunei Darussalam in 1973 to that in 1981?
Offer a very short reply. 0.74. What is the ratio of the Number of enrolments of both sexes in Chile in 1973 to that in 1981?
Your answer should be compact. 0.84. What is the ratio of the Number of enrolments of both sexes in Comoros in 1973 to that in 1981?
Your answer should be very brief. 0.19. What is the ratio of the Number of enrolments of both sexes of Kiribati in 1973 to that in 1981?
Give a very brief answer. 0.51. What is the ratio of the Number of enrolments of both sexes of Brunei Darussalam in 1973 to that in 1986?
Your response must be concise. 0.65. What is the ratio of the Number of enrolments of both sexes of Chile in 1973 to that in 1986?
Keep it short and to the point. 0.71. What is the ratio of the Number of enrolments of both sexes in Comoros in 1973 to that in 1986?
Provide a succinct answer. 0.12. What is the ratio of the Number of enrolments of both sexes of Kiribati in 1973 to that in 1986?
Provide a short and direct response. 0.42. What is the ratio of the Number of enrolments of both sexes in Brunei Darussalam in 1973 to that in 1992?
Provide a succinct answer. 0.49. What is the ratio of the Number of enrolments of both sexes of Chile in 1973 to that in 1992?
Your answer should be very brief. 0.59. What is the ratio of the Number of enrolments of both sexes of Comoros in 1973 to that in 1992?
Ensure brevity in your answer.  0.17. What is the ratio of the Number of enrolments of both sexes in Kiribati in 1973 to that in 1992?
Provide a short and direct response. 0.29. What is the ratio of the Number of enrolments of both sexes in Brunei Darussalam in 1973 to that in 1999?
Make the answer very short. 0.38. What is the ratio of the Number of enrolments of both sexes of Chile in 1973 to that in 1999?
Give a very brief answer. 0.63. What is the ratio of the Number of enrolments of both sexes in Comoros in 1973 to that in 1999?
Make the answer very short. 0.09. What is the ratio of the Number of enrolments of both sexes of Kiribati in 1973 to that in 1999?
Keep it short and to the point. 0.15. What is the ratio of the Number of enrolments of both sexes of Brunei Darussalam in 1974 to that in 1981?
Provide a succinct answer. 0.77. What is the ratio of the Number of enrolments of both sexes of Chile in 1974 to that in 1981?
Keep it short and to the point. 0.87. What is the ratio of the Number of enrolments of both sexes of Comoros in 1974 to that in 1981?
Provide a succinct answer. 0.23. What is the ratio of the Number of enrolments of both sexes of Kiribati in 1974 to that in 1981?
Make the answer very short. 0.56. What is the ratio of the Number of enrolments of both sexes in Brunei Darussalam in 1974 to that in 1986?
Keep it short and to the point. 0.68. What is the ratio of the Number of enrolments of both sexes of Chile in 1974 to that in 1986?
Ensure brevity in your answer.  0.74. What is the ratio of the Number of enrolments of both sexes in Comoros in 1974 to that in 1986?
Make the answer very short. 0.15. What is the ratio of the Number of enrolments of both sexes in Kiribati in 1974 to that in 1986?
Provide a succinct answer. 0.46. What is the ratio of the Number of enrolments of both sexes of Brunei Darussalam in 1974 to that in 1992?
Offer a very short reply. 0.51. What is the ratio of the Number of enrolments of both sexes of Chile in 1974 to that in 1992?
Keep it short and to the point. 0.61. What is the ratio of the Number of enrolments of both sexes in Comoros in 1974 to that in 1992?
Provide a succinct answer. 0.2. What is the ratio of the Number of enrolments of both sexes in Kiribati in 1974 to that in 1992?
Ensure brevity in your answer.  0.31. What is the ratio of the Number of enrolments of both sexes of Brunei Darussalam in 1974 to that in 1999?
Ensure brevity in your answer.  0.4. What is the ratio of the Number of enrolments of both sexes of Chile in 1974 to that in 1999?
Keep it short and to the point. 0.65. What is the ratio of the Number of enrolments of both sexes of Comoros in 1974 to that in 1999?
Your answer should be compact. 0.11. What is the ratio of the Number of enrolments of both sexes of Kiribati in 1974 to that in 1999?
Provide a succinct answer. 0.16. What is the ratio of the Number of enrolments of both sexes of Brunei Darussalam in 1981 to that in 1986?
Provide a short and direct response. 0.88. What is the ratio of the Number of enrolments of both sexes in Chile in 1981 to that in 1986?
Give a very brief answer. 0.85. What is the ratio of the Number of enrolments of both sexes in Comoros in 1981 to that in 1986?
Make the answer very short. 0.66. What is the ratio of the Number of enrolments of both sexes in Kiribati in 1981 to that in 1986?
Ensure brevity in your answer.  0.82. What is the ratio of the Number of enrolments of both sexes in Brunei Darussalam in 1981 to that in 1992?
Offer a terse response. 0.67. What is the ratio of the Number of enrolments of both sexes in Chile in 1981 to that in 1992?
Your answer should be compact. 0.7. What is the ratio of the Number of enrolments of both sexes of Comoros in 1981 to that in 1992?
Make the answer very short. 0.87. What is the ratio of the Number of enrolments of both sexes in Kiribati in 1981 to that in 1992?
Keep it short and to the point. 0.57. What is the ratio of the Number of enrolments of both sexes of Brunei Darussalam in 1981 to that in 1999?
Offer a very short reply. 0.52. What is the ratio of the Number of enrolments of both sexes of Chile in 1981 to that in 1999?
Offer a terse response. 0.75. What is the ratio of the Number of enrolments of both sexes in Comoros in 1981 to that in 1999?
Provide a short and direct response. 0.48. What is the ratio of the Number of enrolments of both sexes of Kiribati in 1981 to that in 1999?
Give a very brief answer. 0.29. What is the ratio of the Number of enrolments of both sexes of Brunei Darussalam in 1986 to that in 1992?
Offer a terse response. 0.76. What is the ratio of the Number of enrolments of both sexes of Chile in 1986 to that in 1992?
Provide a succinct answer. 0.83. What is the ratio of the Number of enrolments of both sexes of Comoros in 1986 to that in 1992?
Give a very brief answer. 1.33. What is the ratio of the Number of enrolments of both sexes in Kiribati in 1986 to that in 1992?
Ensure brevity in your answer.  0.69. What is the ratio of the Number of enrolments of both sexes of Brunei Darussalam in 1986 to that in 1999?
Keep it short and to the point. 0.59. What is the ratio of the Number of enrolments of both sexes of Chile in 1986 to that in 1999?
Give a very brief answer. 0.88. What is the ratio of the Number of enrolments of both sexes of Comoros in 1986 to that in 1999?
Your response must be concise. 0.73. What is the ratio of the Number of enrolments of both sexes of Kiribati in 1986 to that in 1999?
Offer a terse response. 0.35. What is the ratio of the Number of enrolments of both sexes of Brunei Darussalam in 1992 to that in 1999?
Your response must be concise. 0.78. What is the ratio of the Number of enrolments of both sexes of Chile in 1992 to that in 1999?
Give a very brief answer. 1.07. What is the ratio of the Number of enrolments of both sexes of Comoros in 1992 to that in 1999?
Give a very brief answer. 0.55. What is the ratio of the Number of enrolments of both sexes in Kiribati in 1992 to that in 1999?
Ensure brevity in your answer.  0.51. What is the difference between the highest and the second highest Number of enrolments of both sexes of Brunei Darussalam?
Your response must be concise. 7590. What is the difference between the highest and the second highest Number of enrolments of both sexes in Chile?
Offer a terse response. 8.59e+04. What is the difference between the highest and the second highest Number of enrolments of both sexes in Comoros?
Offer a terse response. 7662. What is the difference between the highest and the second highest Number of enrolments of both sexes of Kiribati?
Provide a succinct answer. 3290. What is the difference between the highest and the lowest Number of enrolments of both sexes of Brunei Darussalam?
Offer a terse response. 2.26e+04. What is the difference between the highest and the lowest Number of enrolments of both sexes of Chile?
Your response must be concise. 7.01e+05. What is the difference between the highest and the lowest Number of enrolments of both sexes in Comoros?
Make the answer very short. 2.74e+04. What is the difference between the highest and the lowest Number of enrolments of both sexes of Kiribati?
Your answer should be very brief. 5751. 